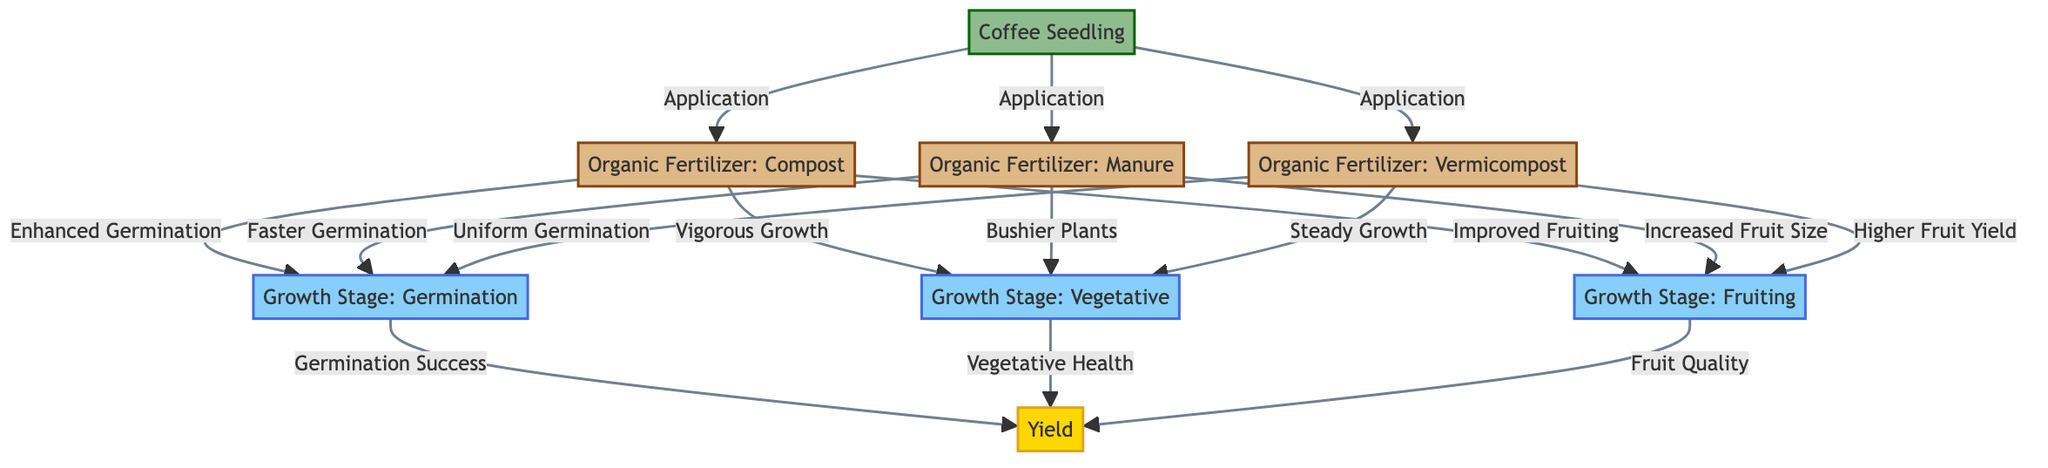What is the first stage of coffee plant growth represented in the diagram? The first stage of coffee plant growth in the diagram is labeled as "Coffee Seedling." This is the initial node before any fertilizers are applied.
Answer: Coffee Seedling How many types of organic fertilizers are listed in the diagram? The diagram lists three types of organic fertilizers: Compost, Manure, and Vermicompost. To find this, I counted the fertilizer nodes connected to the coffee seedling.
Answer: 3 What effect does Manure have on the germination stage? Manure is connected to the growth stage labeled "Germination" with the description "Faster Germination." This indicates that the application of manure enhances the germination process of the coffee seedling.
Answer: Faster Germination Which organic fertilizer is associated with "Higher Fruit Yield"? The diagram shows that "Higher Fruit Yield" is linked to "Vermicompost." This means that the use of vermicompost is expected to produce a higher yield of coffee fruit.
Answer: Vermicompost What are the effects of Compost on vegetative growth? From the diagram, Compost is linked to the growth stage "Vegetative" with the effect labeled as "Vigorous Growth." This indicates that compost enhances the vegetative stage of coffee plants.
Answer: Vigorous Growth How does the "Germination Success" relate to the yield of coffee plants? The diagram connects "Germination Success" to "Yield." This indicates that successful germination directly contributes to the overall yield of coffee plants.
Answer: Germination Success What is the overall impact of applying Organic Fertilizers on fruiting? The diagram illustrates that all three organic fertilizers enhance the "Fruiting" stage with specific improvements: "Improved Fruiting" for Compost, "Increased Fruit Size" for Manure, and "Higher Fruit Yield" for Vermicompost. This shows a positive impact from each fertilizer type on the fruiting stage.
Answer: Enhanced Fruiting What is the final outcome for the yield of coffee plants? The diagram shows that the yield of coffee plants is linked to three growth stages: Germination Success, Vegetative Health, and Fruit Quality. Thus, the final outcome for yield integrates these three aspects.
Answer: Yield What is the link between Vegetative Health and coffee yield? "Vegetative Health" is shown connected to "Yield" in the diagram. This means that maintaining healthy vegetative growth leads to a positive increase in yield.
Answer: Vegetative Health 